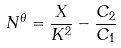<formula> <loc_0><loc_0><loc_500><loc_500>N ^ { \theta } = \frac { X } { K ^ { 2 } } - \frac { C _ { 2 } } { C _ { 1 } }</formula> 